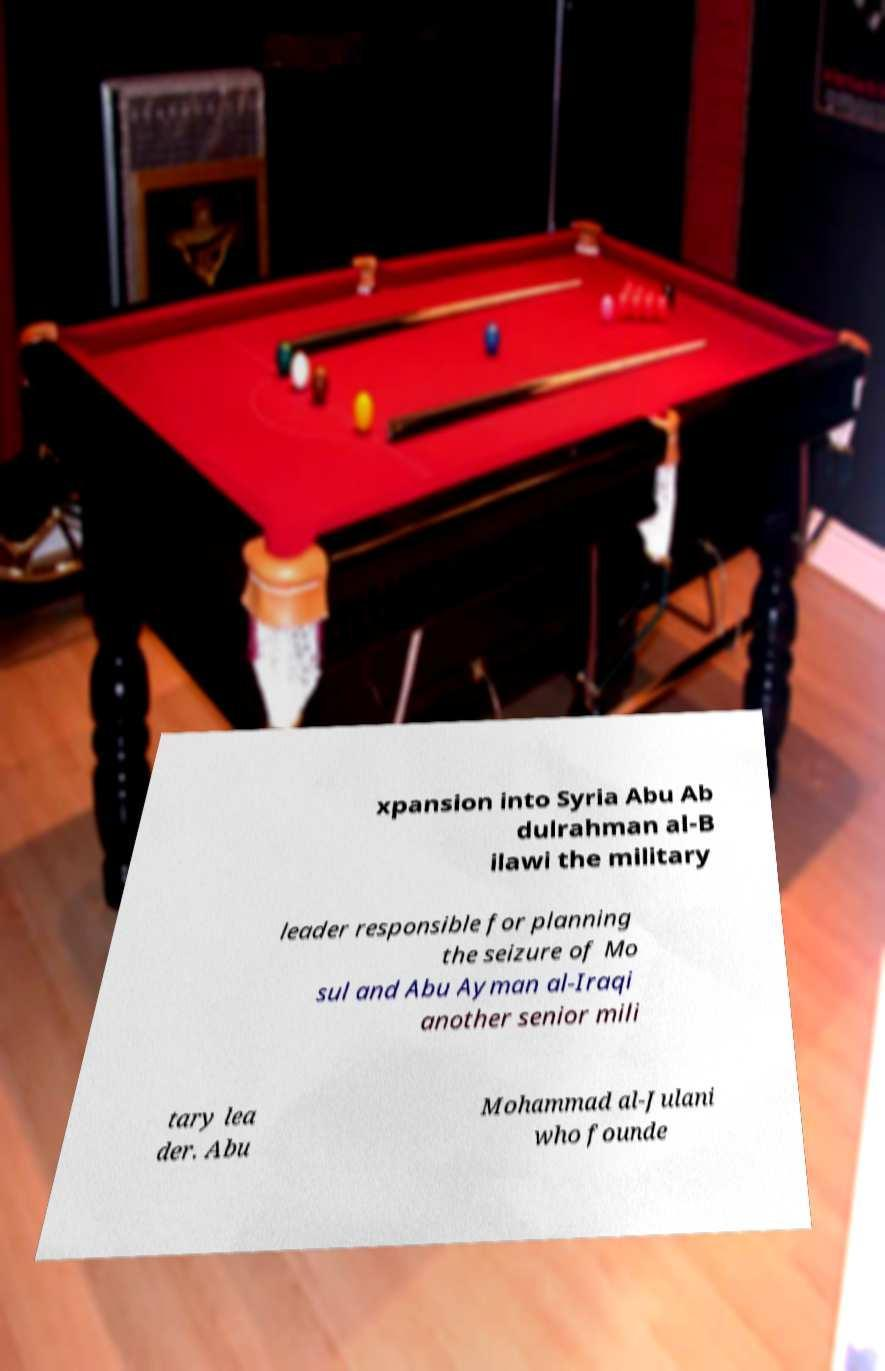There's text embedded in this image that I need extracted. Can you transcribe it verbatim? xpansion into Syria Abu Ab dulrahman al-B ilawi the military leader responsible for planning the seizure of Mo sul and Abu Ayman al-Iraqi another senior mili tary lea der. Abu Mohammad al-Julani who founde 